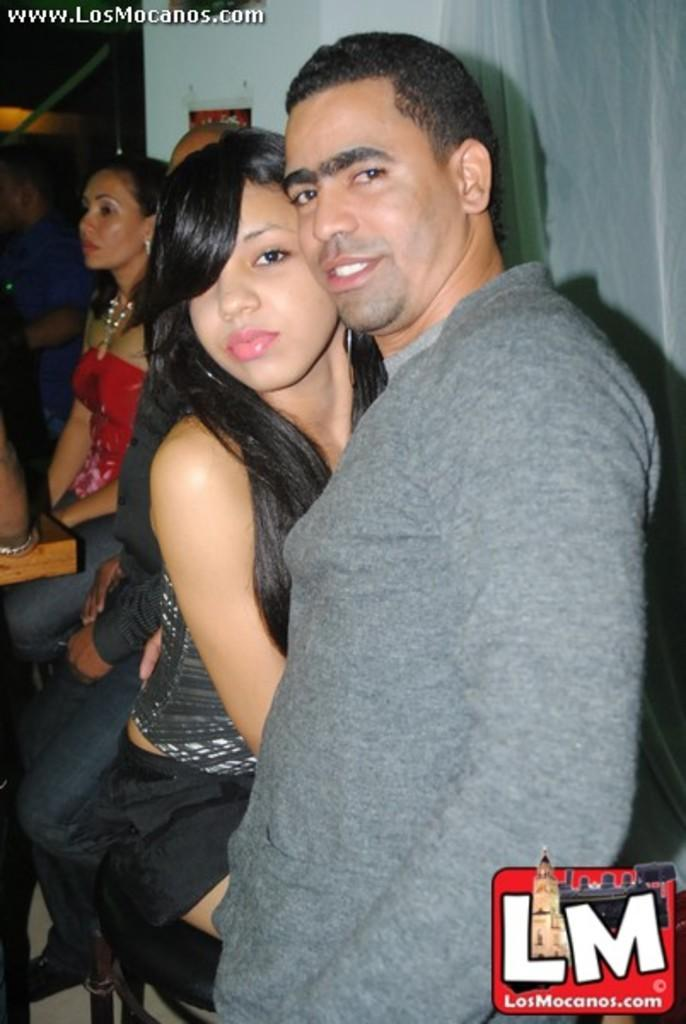How many people are in the image? There is a group of people in the image, but the exact number cannot be determined from the provided facts. What is hanging in the background of the image? There is a curtain visible in the image. What type of structure is visible in the image? There is a wall visible in the image. Is there a ghost visible in the image? There is no mention of a ghost in the provided facts, so we cannot determine if one is present in the image. 